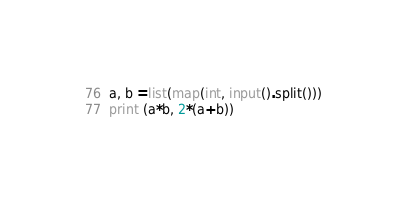<code> <loc_0><loc_0><loc_500><loc_500><_Python_>a, b =list(map(int, input().split()))
print (a*b, 2*(a+b))</code> 